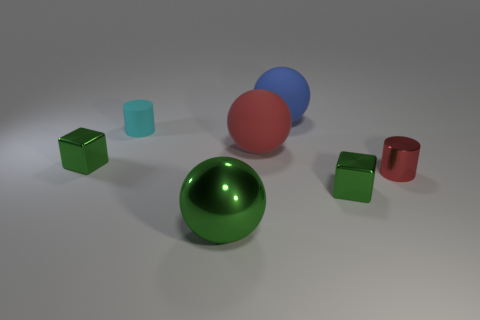Add 2 small red things. How many objects exist? 9 Subtract all cubes. How many objects are left? 5 Add 6 tiny things. How many tiny things are left? 10 Add 6 metal cylinders. How many metal cylinders exist? 7 Subtract 1 green spheres. How many objects are left? 6 Subtract all metal blocks. Subtract all metal spheres. How many objects are left? 4 